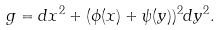Convert formula to latex. <formula><loc_0><loc_0><loc_500><loc_500>g = d x ^ { 2 } + ( \phi ( x ) + \psi ( y ) ) ^ { 2 } d y ^ { 2 } .</formula> 